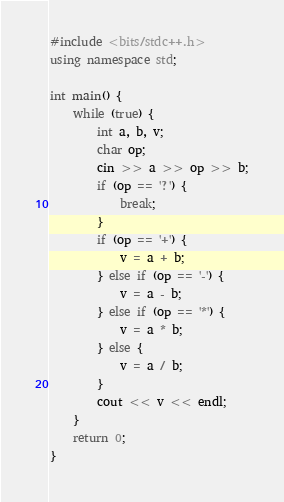<code> <loc_0><loc_0><loc_500><loc_500><_C++_>#include <bits/stdc++.h>
using namespace std;

int main() {
    while (true) {
        int a, b, v;
        char op;
        cin >> a >> op >> b;
        if (op == '?') {
            break;
        }
        if (op == '+') {
            v = a + b;
        } else if (op == '-') {
            v = a - b;
        } else if (op == '*') {
            v = a * b;
        } else {
            v = a / b;
        }
        cout << v << endl;
    }
    return 0;
}
</code> 